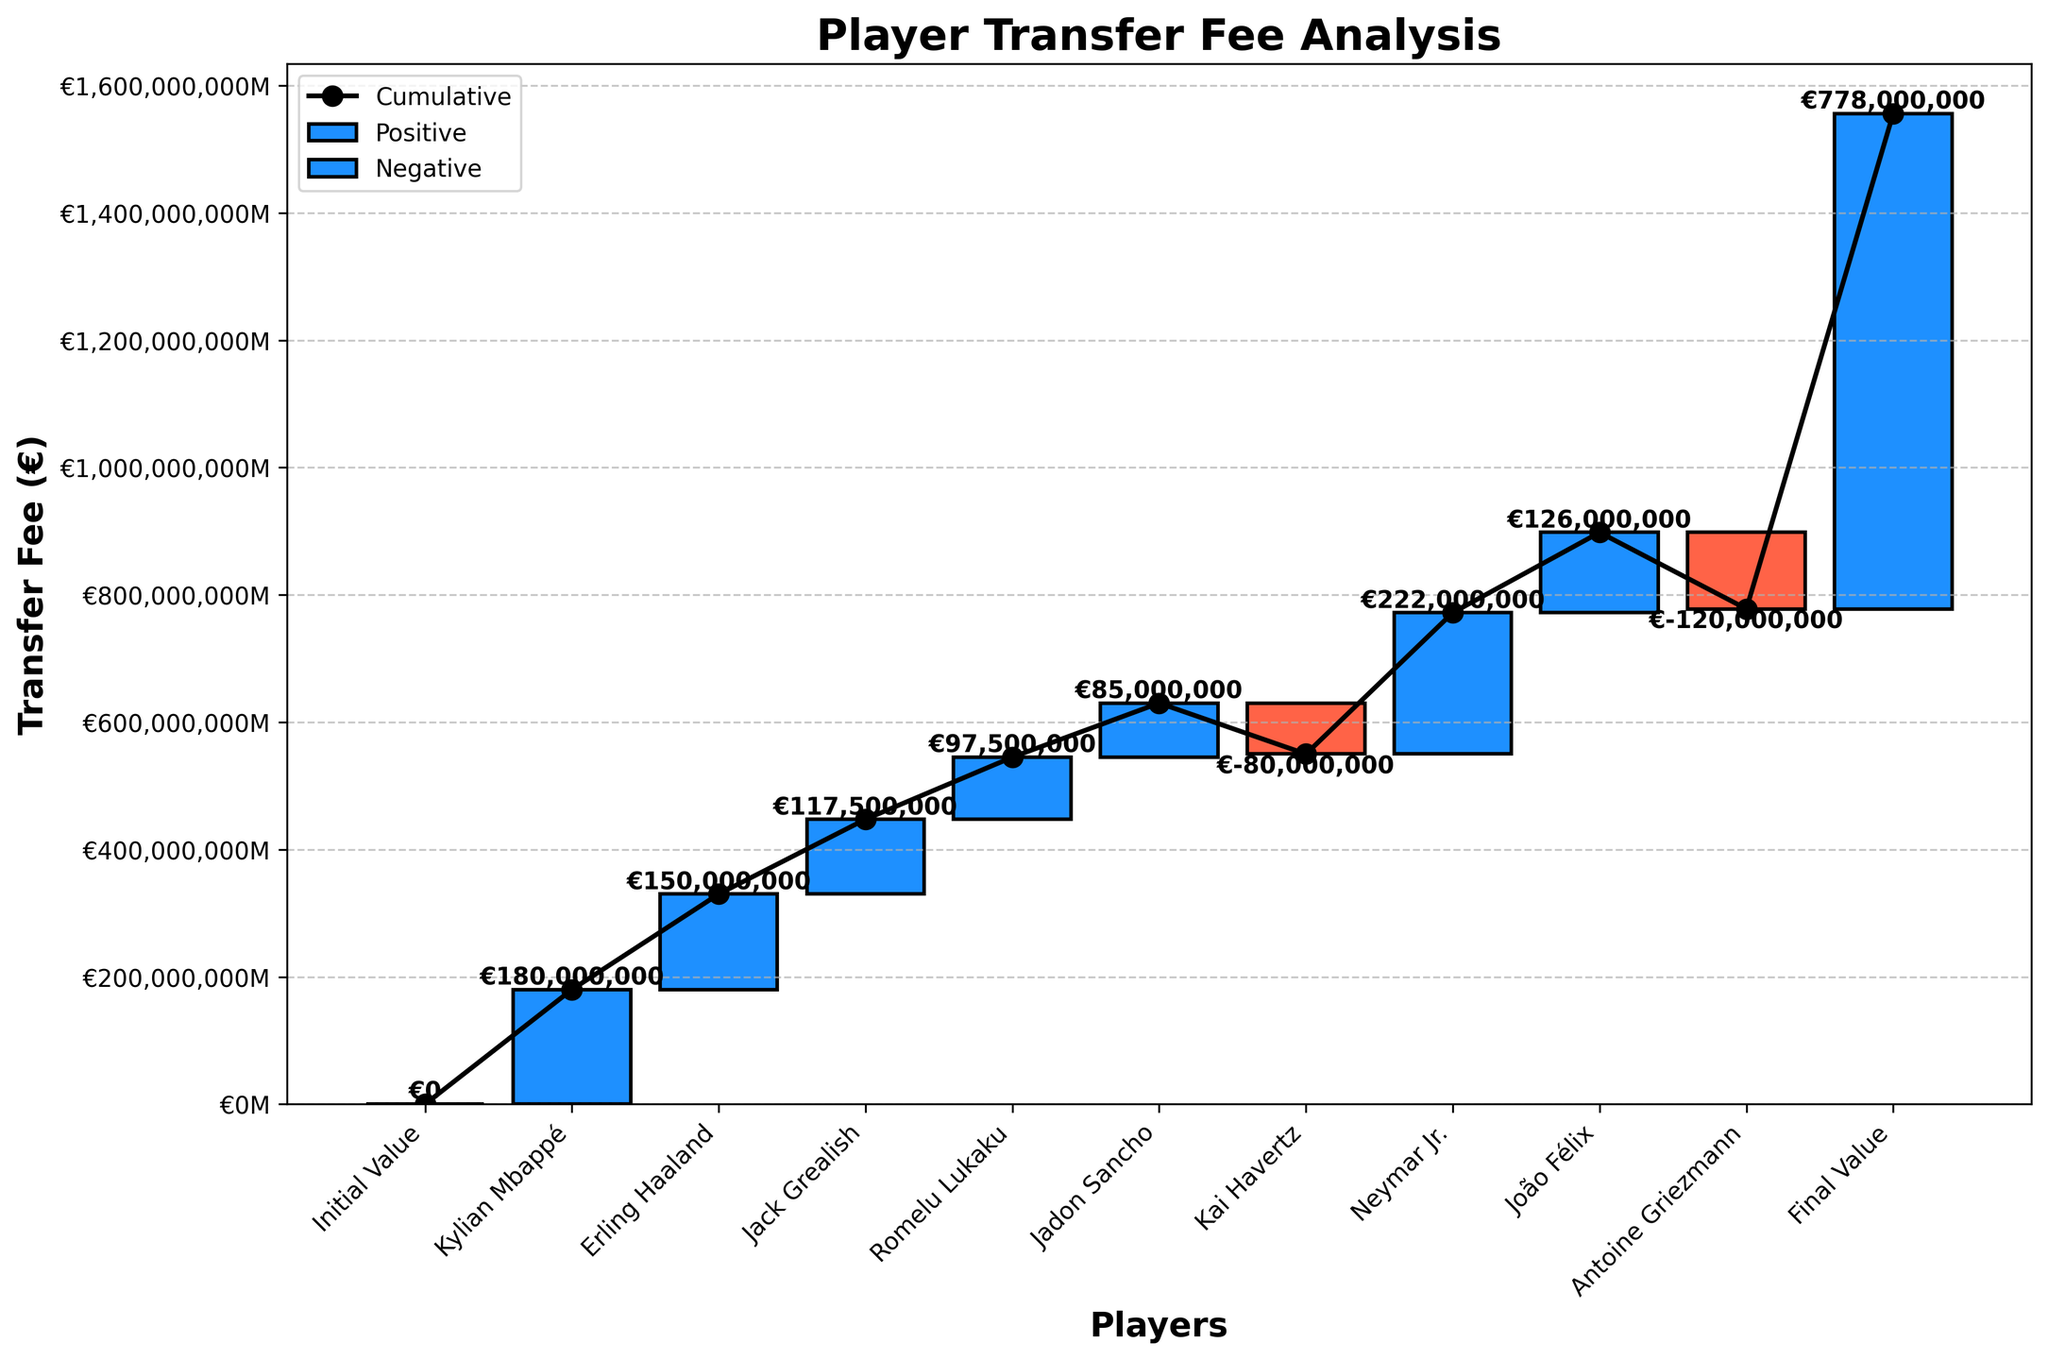what is the title of the figure? The title of the figure is usually located at the top of the chart. It summarizes what the chart represents.
Answer: Player Transfer Fee Analysis how many players have negative transfer fees? Count the number of bars colored in the style that represents negative values.
Answer: 2 what is the cumulative transfer fee value at the end of the graph? The cumulative value at the last point should match the final sum of all the incremental changes shown.
Answer: €778,000,000 which player has the highest transfer fee in the chart? Identify the player associated with the tallest bar in the chart representing the largest value.
Answer: Neymar Jr how many players have positive transfer fees? Count the number of bars colored in the style that represents positive values.
Answer: 7 how does Antoine Griezmann's transfer fee compare to Jack Grealish's? Compare the heights of the bars for Antoine Griezmann and Jack Grealish. Antoine Griezmann has a negative transfer fee, so it is less than Jack Grealish's.
Answer: Less than what would be the cumulative transfer fee value if Kai Havertz's transfer was not included? Subtract Kai Havertz's transfer fee from the final cumulative value. The cumulative at the end is €778,000,000 - €80,000,000 = €698,000,000.
Answer: €698,000,000 what is the range of transfer fees in the chart? Identify the maximum and minimum transfer fees (Neymar Jr.'s and Antoine Griezmann's) and find the difference: €222,000,000 - (-€120,000,000) = €342,000,000.
Answer: €342,000,000 which section of the graph (positive or negative) has a greater total transfer fee contribution? Sum the transfer fees of players with positive values and compare it to the sum of negative values. The positive contributions will be higher since there are more positive fees.
Answer: Positive section 